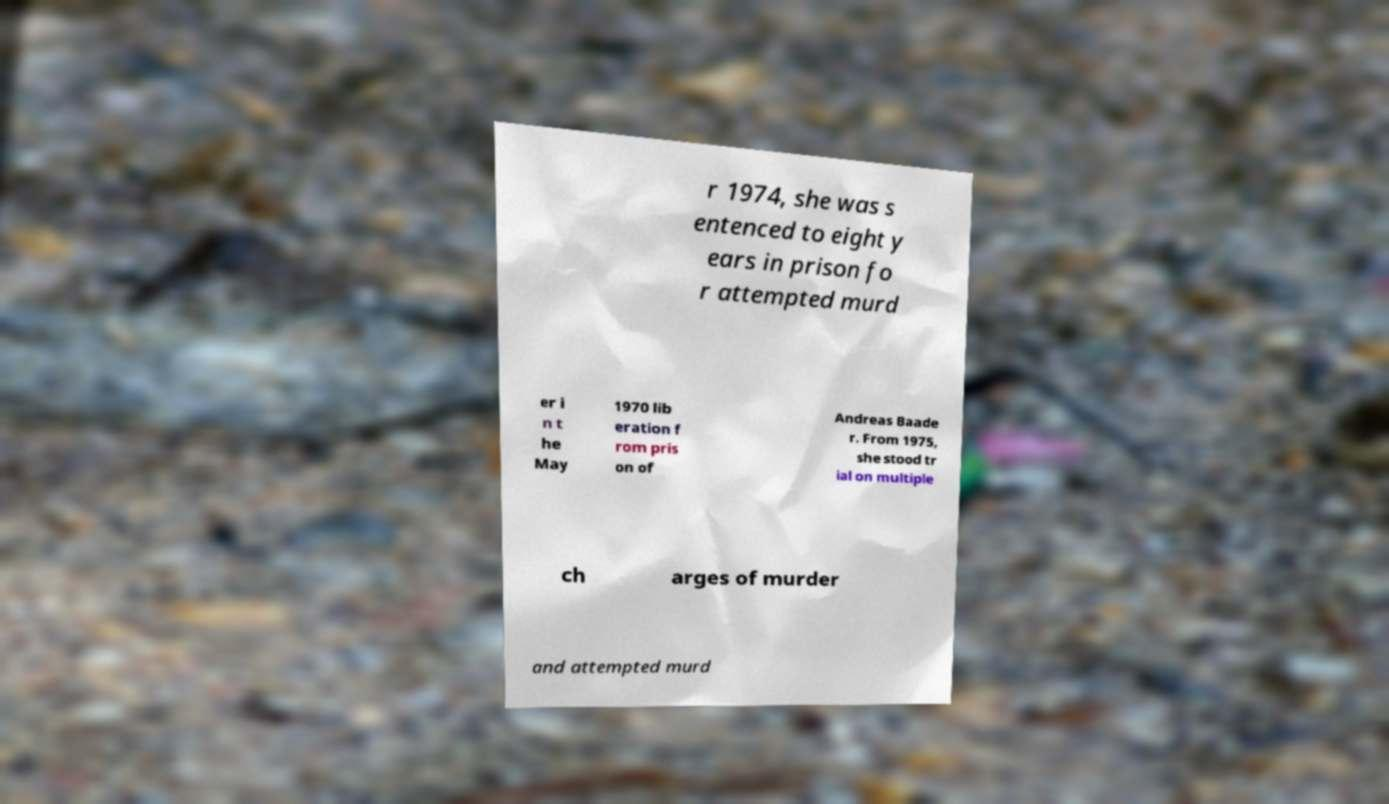For documentation purposes, I need the text within this image transcribed. Could you provide that? r 1974, she was s entenced to eight y ears in prison fo r attempted murd er i n t he May 1970 lib eration f rom pris on of Andreas Baade r. From 1975, she stood tr ial on multiple ch arges of murder and attempted murd 